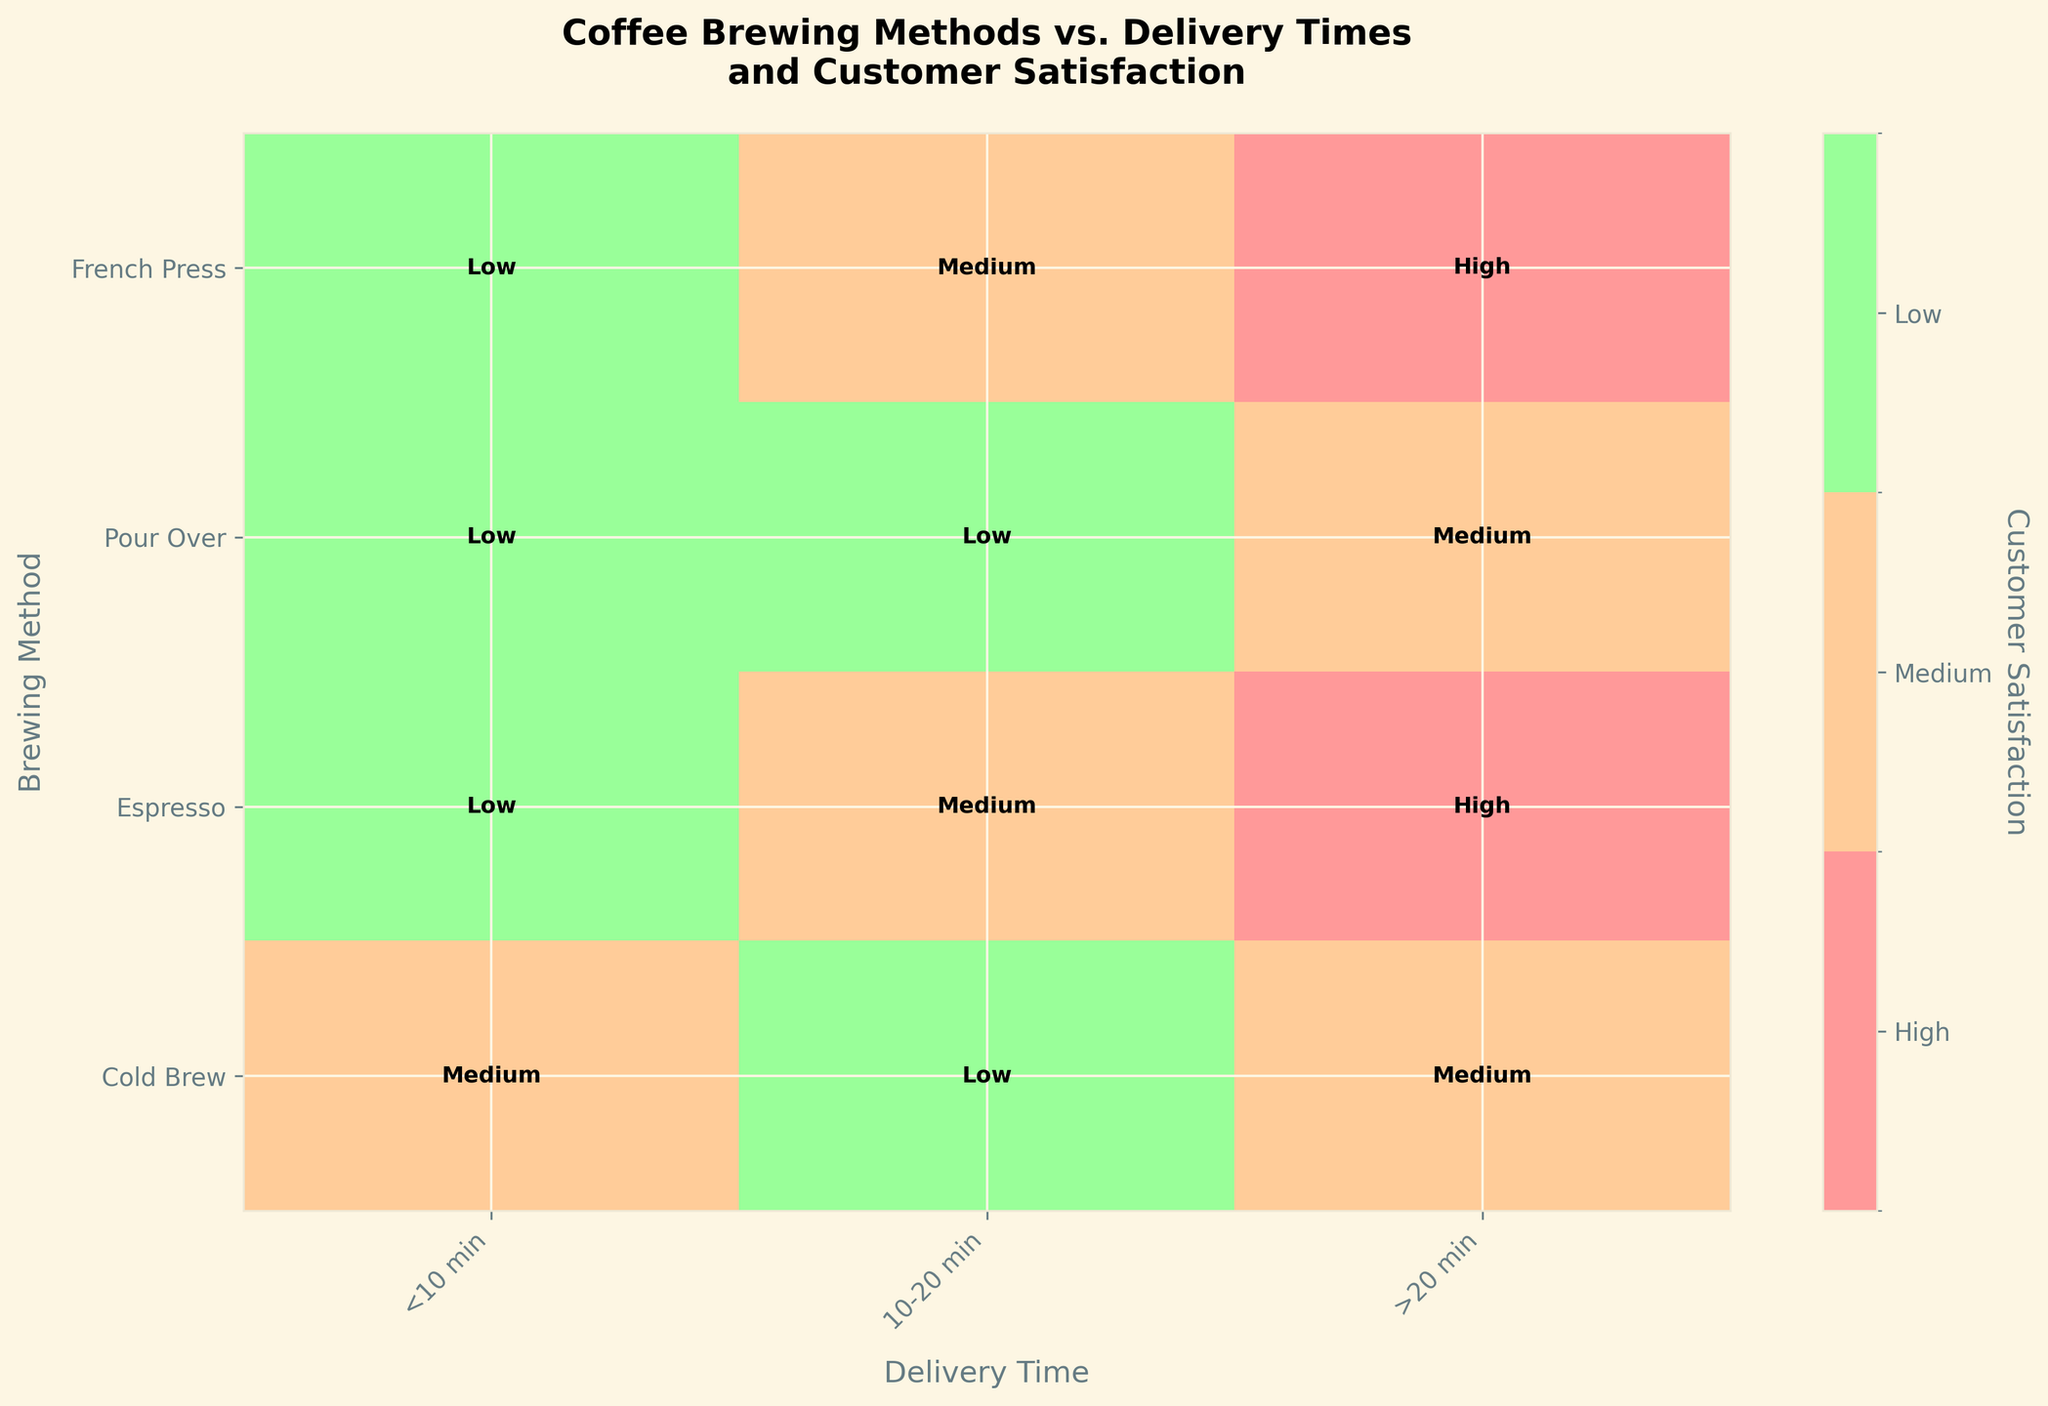What is the title of the figure? The title of the figure is usually displayed at the top. Look for the large text that summarizes the content of the figure.
Answer: Coffee Brewing Methods vs. Delivery Times and Customer Satisfaction How many delivery times are represented in the figure? Count the number of unique delivery times listed along the x-axis to determine how many there are.
Answer: 3 Which brewing method has high customer satisfaction with a delivery time less than 10 minutes? Find the row corresponding to high customer satisfaction and the column under "<10 min" delivery time to identify the brewing method.
Answer: French Press, Pour Over, Espresso Which customer satisfaction level is most common for the Cold Brew method across all delivery times? Check each cell corresponding to the Cold Brew method and count the frequency of each customer satisfaction level.
Answer: Medium How does the customer satisfaction level change with increasing delivery time for the Espresso brewing method? Start from the "<10 min" column in the Espresso row and move right, noting if the satisfaction level increases, decreases, or stays the same.
Answer: It decreases from High to Medium to Low Which brewing method achieves the highest customer satisfaction for delivery times of 10-20 minutes? Look at the "10-20 min" column and identify which brewing method corresponds to the high satisfaction level.
Answer: Pour Over, Cold Brew What is the difference in customer satisfaction between the highest-rated and lowest-rated delivery time for the French Press method? Note the satisfaction levels for <10 min, 10-20 min, and >20 min for French Press, then compute the difference between the highest and lowest levels.
Answer: High - Low For which brewing method does the customer satisfaction not vary with delivery time? Scan each method to see if all the cells in a method's row have the same satisfaction level.
Answer: None Which delivery time category has the most occurrences of medium customer satisfaction across all brewing methods? Tally the "Medium" satisfaction levels for each delivery time category and identify the one with the highest count.
Answer: >20 min 